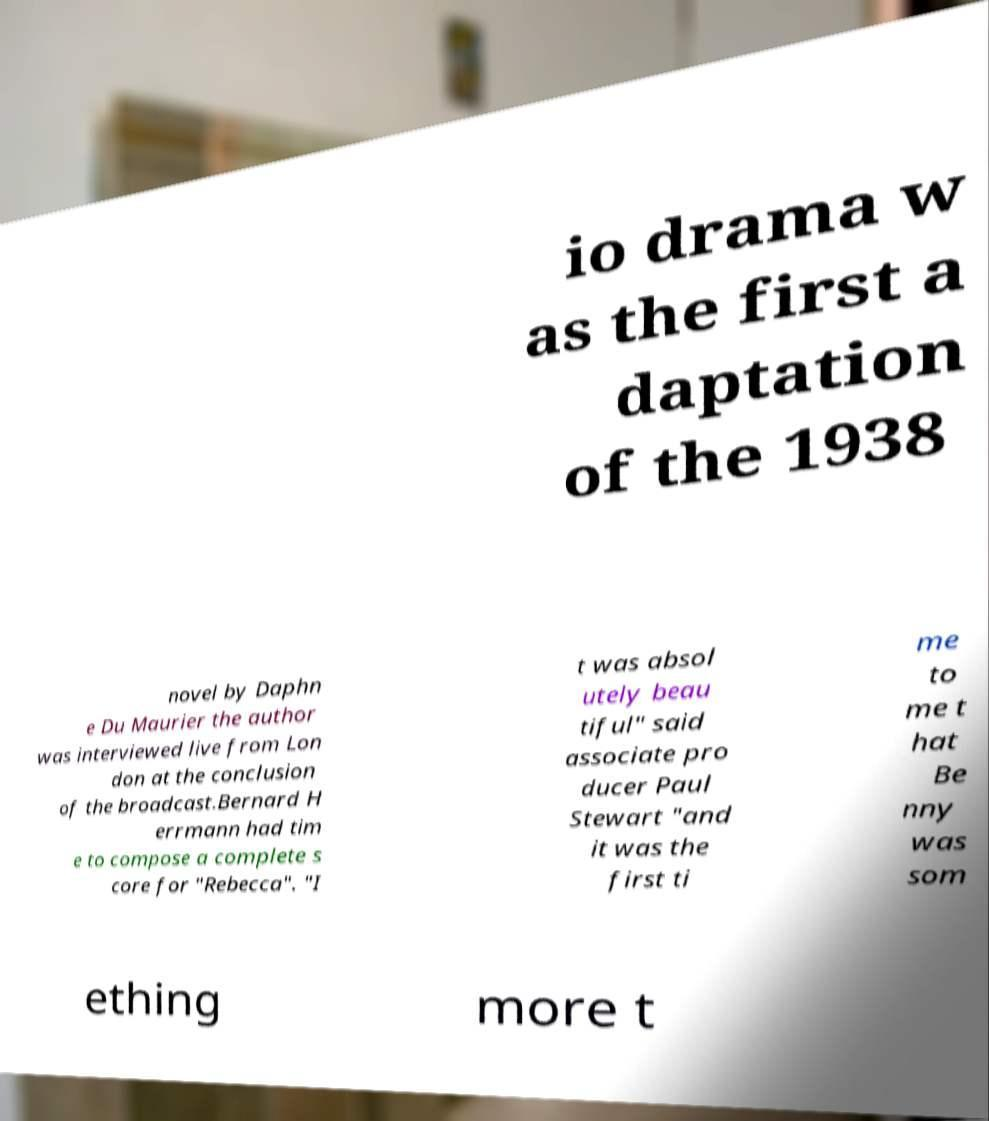Can you read and provide the text displayed in the image?This photo seems to have some interesting text. Can you extract and type it out for me? io drama w as the first a daptation of the 1938 novel by Daphn e Du Maurier the author was interviewed live from Lon don at the conclusion of the broadcast.Bernard H errmann had tim e to compose a complete s core for "Rebecca". "I t was absol utely beau tiful" said associate pro ducer Paul Stewart "and it was the first ti me to me t hat Be nny was som ething more t 